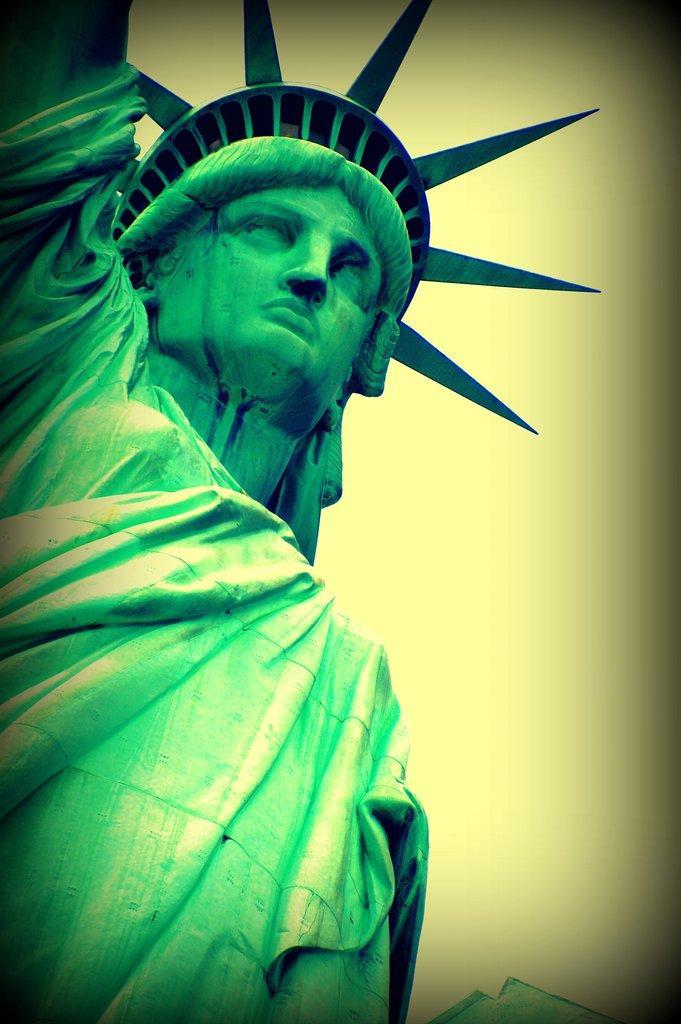Describe this image in one or two sentences. In this picture I can see The Statue of Liberty in front and I can see the background which is of light in yellow in color. 